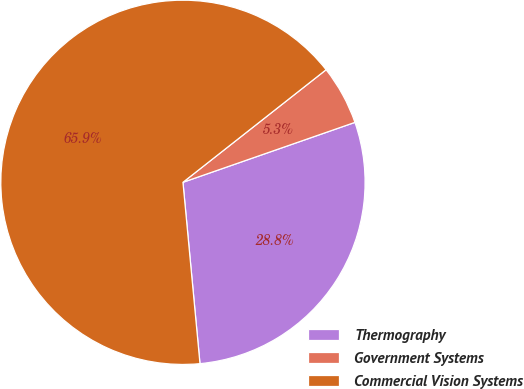<chart> <loc_0><loc_0><loc_500><loc_500><pie_chart><fcel>Thermography<fcel>Government Systems<fcel>Commercial Vision Systems<nl><fcel>28.85%<fcel>5.27%<fcel>65.89%<nl></chart> 